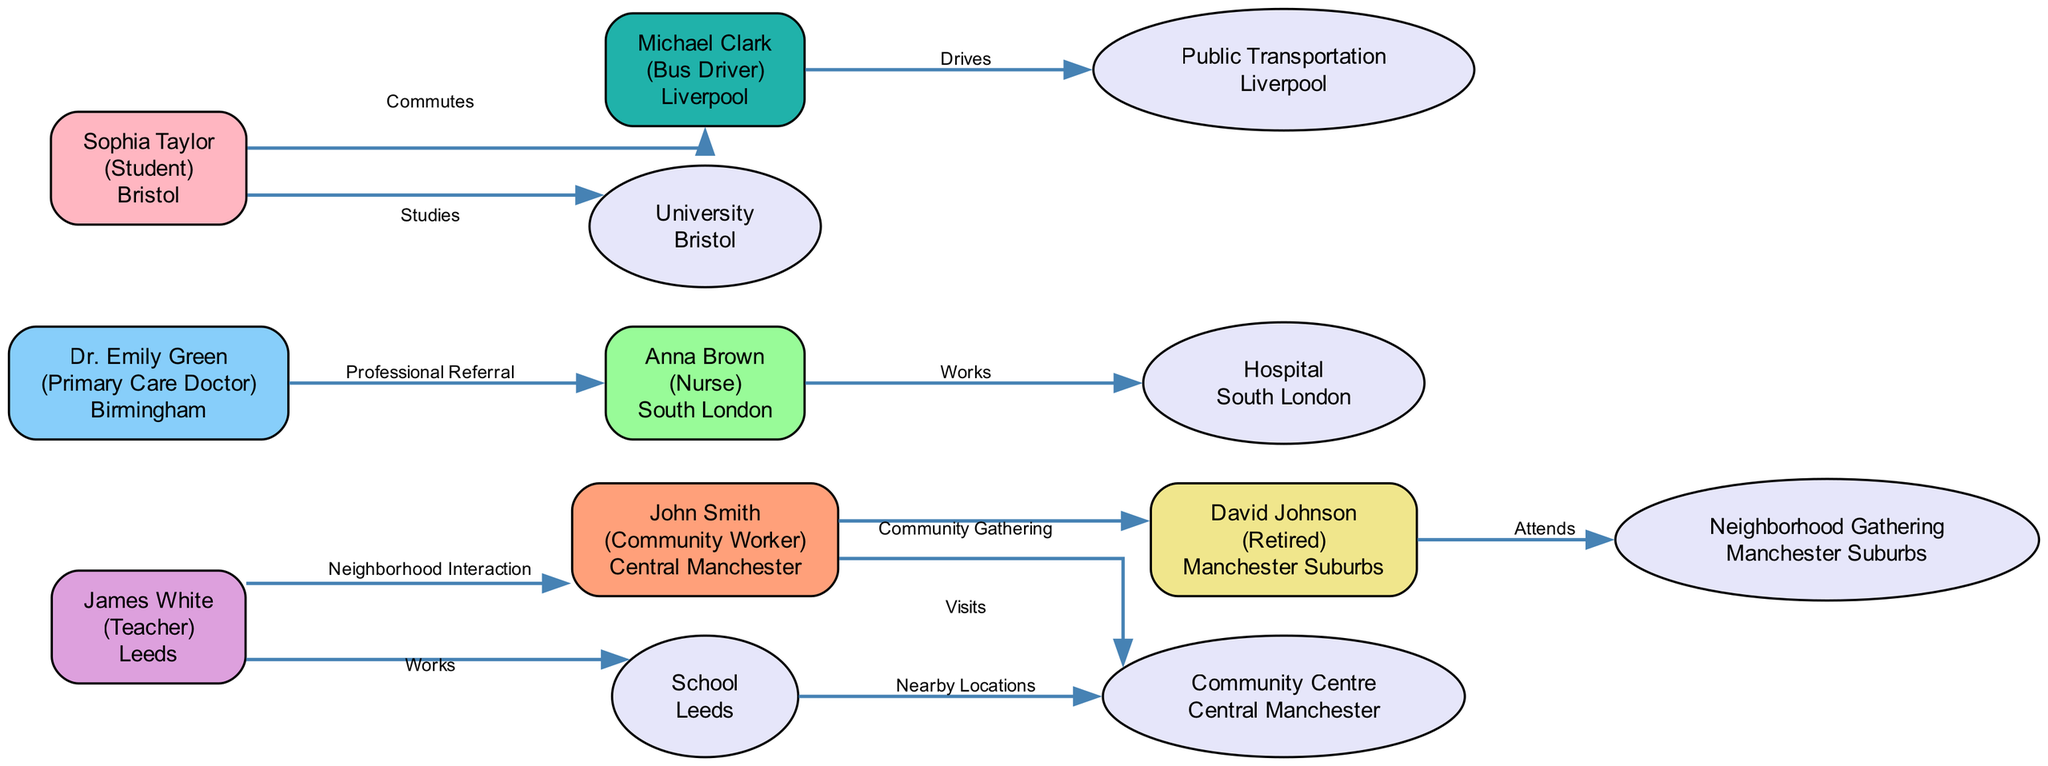What is the role of John Smith? John Smith's node indicates that his role is "Community Worker," which is listed directly under his name in the diagram.
Answer: Community Worker How many nodes represent individuals in the diagram? The diagram contains seven nodes representing individuals, all starting with "person" in their ID (person_1 to person_7).
Answer: 7 Which place does Anna Brown work at? The edge connected to Anna Brown shows the label "Works" directed towards "Hospital," indicating that she is employed there according to the information in the diagram.
Answer: Hospital What kind of interaction does James White have with John Smith? The edge labeled "Neighborhood Interaction" connects James White to John Smith, indicating that they have a specific relationship defined in this manner in the diagram.
Answer: Neighborhood Interaction Which city is Sophia Taylor studying in? The node for Sophia Taylor specifies she studies at "University" located in "Bristol," which is referenced directly beneath her name.
Answer: Bristol How many edges are connected to David Johnson? Upon inspecting the diagram, there is only one edge connected to David Johnson, indicating his interaction with the "Neighborhood Gathering" place.
Answer: 1 Which person is connected to the "Community Centre" node? The edge labeled "Visits" from "John Smith" to "Community Centre" indicates his connection to this particular place.
Answer: John Smith What is the relationship type between Dr. Emily Green and Anna Brown? The diagram shows an edge labeled "Professional Referral" from Dr. Emily Green to Anna Brown, which denotes the nature of their linkage.
Answer: Professional Referral Which individual drives the public transportation in Liverpool? The edge labeled "Drives" connected from Michael Clark to "Public Transportation" indicates that he performs this role in Liverpool.
Answer: Michael Clark 